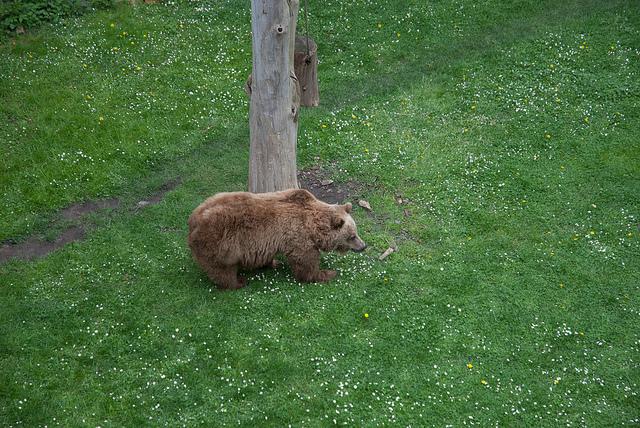What is the bear at the bottom of?
Give a very brief answer. Tree. What type of greenery has grown from the ground?
Give a very brief answer. Grass. Is the bear climbing the tree?
Concise answer only. No. 